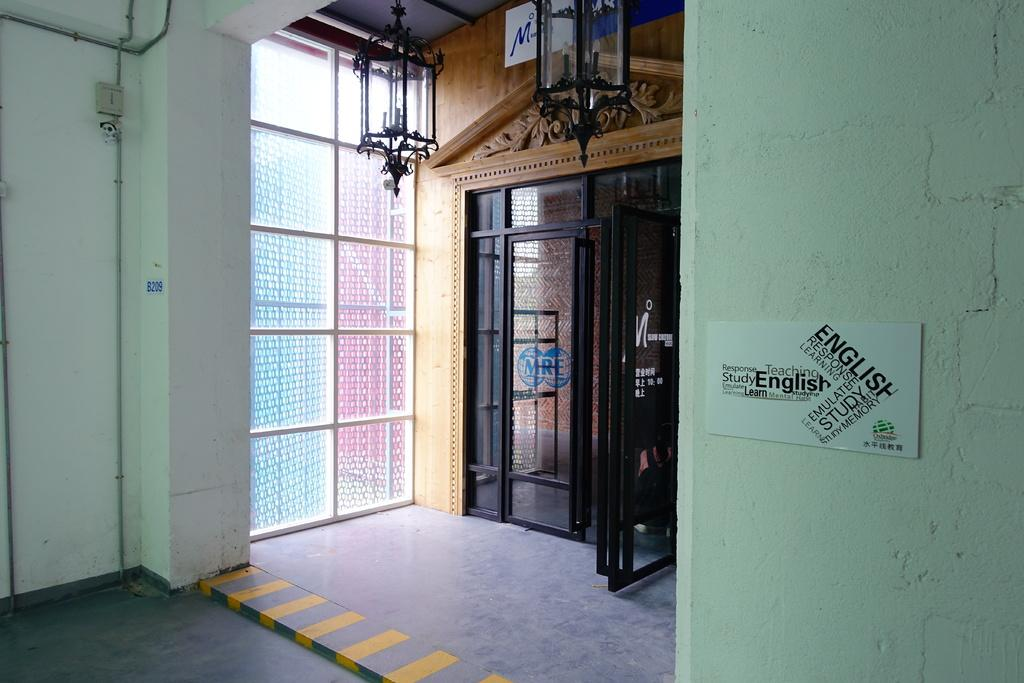Where was the image taken? The image was taken in a building. What can be seen in the center of the image? There is a door in the center of the image. What is present on the sides of the image? There is a wall in the image. What is placed on the wall? A board is placed on the wall. What is visible at the top of the image? There are chandeliers at the top of the image. What type of authority figure can be seen in the image? There is no authority figure present in the image. What kind of cloud formation is visible through the window in the image? There is no window or cloud formation visible in the image. 